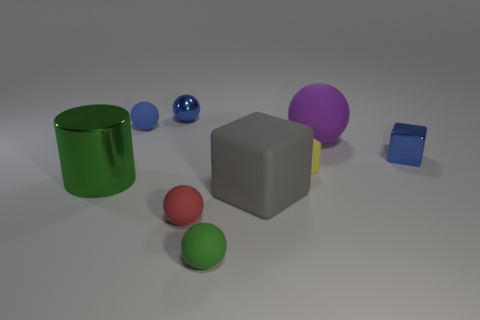Subtract all gray spheres. Subtract all blue blocks. How many spheres are left? 5 Subtract all balls. How many objects are left? 4 Add 5 tiny blue balls. How many tiny blue balls are left? 7 Add 6 red matte cylinders. How many red matte cylinders exist? 6 Subtract 0 purple cylinders. How many objects are left? 9 Subtract all big gray things. Subtract all large red matte cubes. How many objects are left? 8 